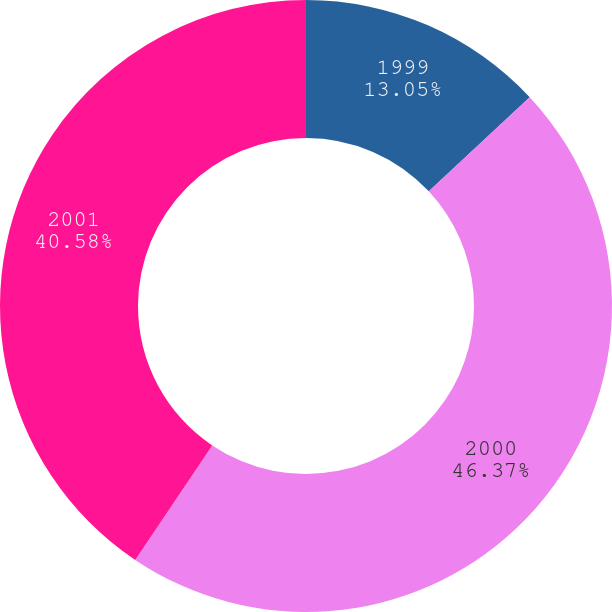Convert chart. <chart><loc_0><loc_0><loc_500><loc_500><pie_chart><fcel>1999<fcel>2000<fcel>2001<nl><fcel>13.05%<fcel>46.38%<fcel>40.58%<nl></chart> 